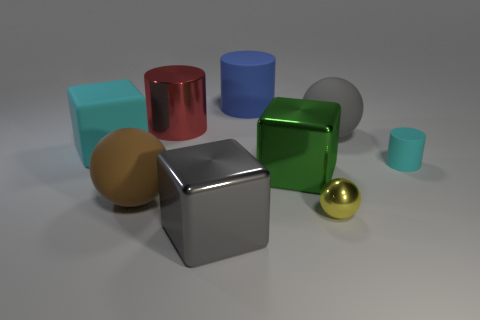What is the big block behind the cyan object that is right of the small yellow metal ball made of?
Make the answer very short. Rubber. There is another tiny object that is the same shape as the brown object; what is it made of?
Provide a succinct answer. Metal. There is a matte ball to the right of the blue cylinder; is it the same size as the cyan cylinder?
Provide a succinct answer. No. What number of rubber objects are big blue cubes or big green blocks?
Ensure brevity in your answer.  0. What material is the sphere that is both in front of the small cyan cylinder and to the right of the blue matte cylinder?
Provide a short and direct response. Metal. Is the cyan cube made of the same material as the large gray sphere?
Provide a succinct answer. Yes. How big is the rubber thing that is both to the left of the red metal object and behind the green metal cube?
Ensure brevity in your answer.  Large. What shape is the big cyan object?
Ensure brevity in your answer.  Cube. What number of things are either tiny blue metallic spheres or big cubes left of the green shiny cube?
Give a very brief answer. 2. Does the rubber cylinder on the right side of the tiny metallic ball have the same color as the matte block?
Provide a short and direct response. Yes. 